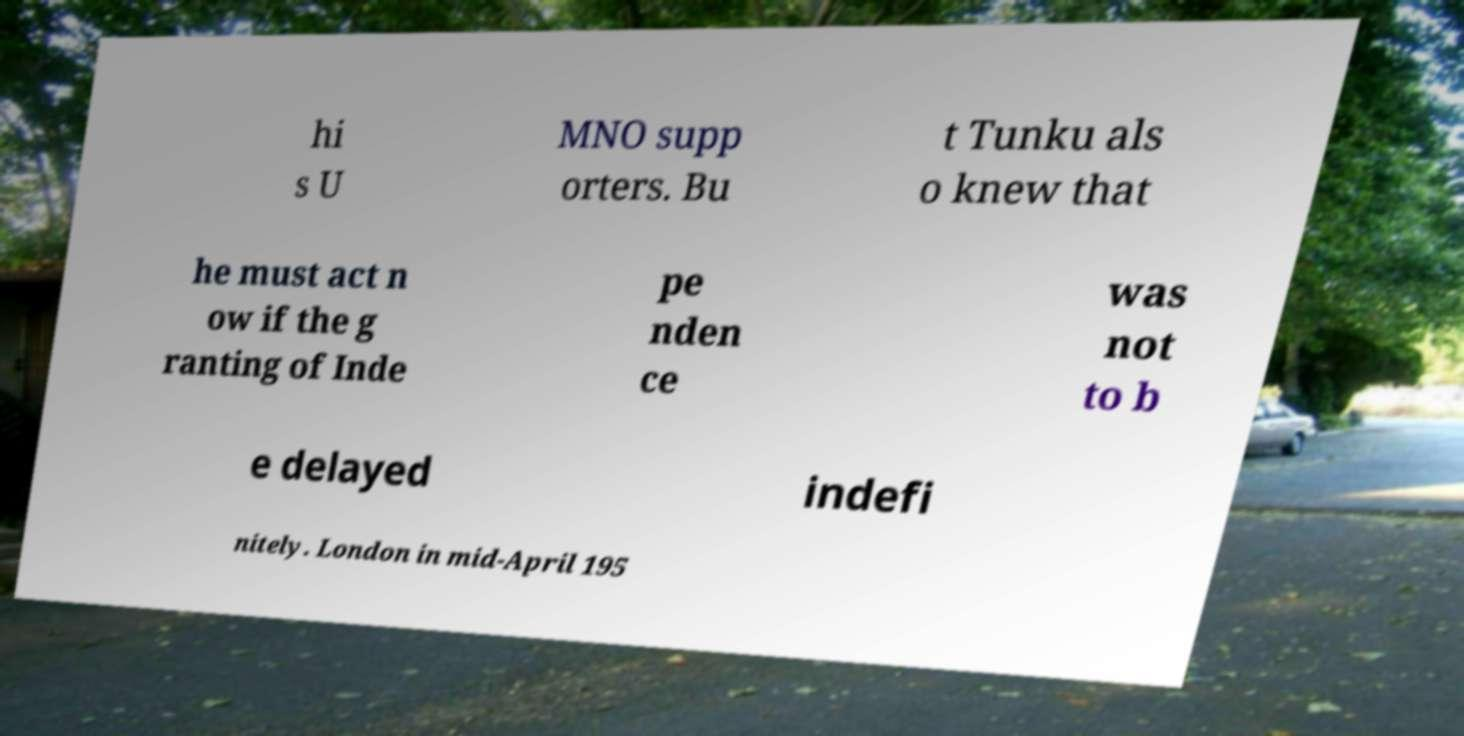Please identify and transcribe the text found in this image. hi s U MNO supp orters. Bu t Tunku als o knew that he must act n ow if the g ranting of Inde pe nden ce was not to b e delayed indefi nitely. London in mid-April 195 